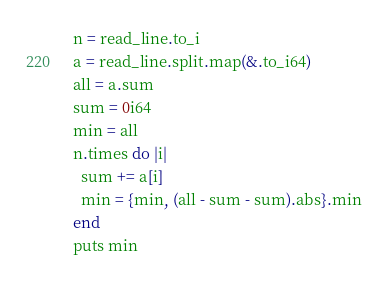<code> <loc_0><loc_0><loc_500><loc_500><_Crystal_>n = read_line.to_i
a = read_line.split.map(&.to_i64)
all = a.sum
sum = 0i64
min = all
n.times do |i|
  sum += a[i]
  min = {min, (all - sum - sum).abs}.min
end
puts min
</code> 